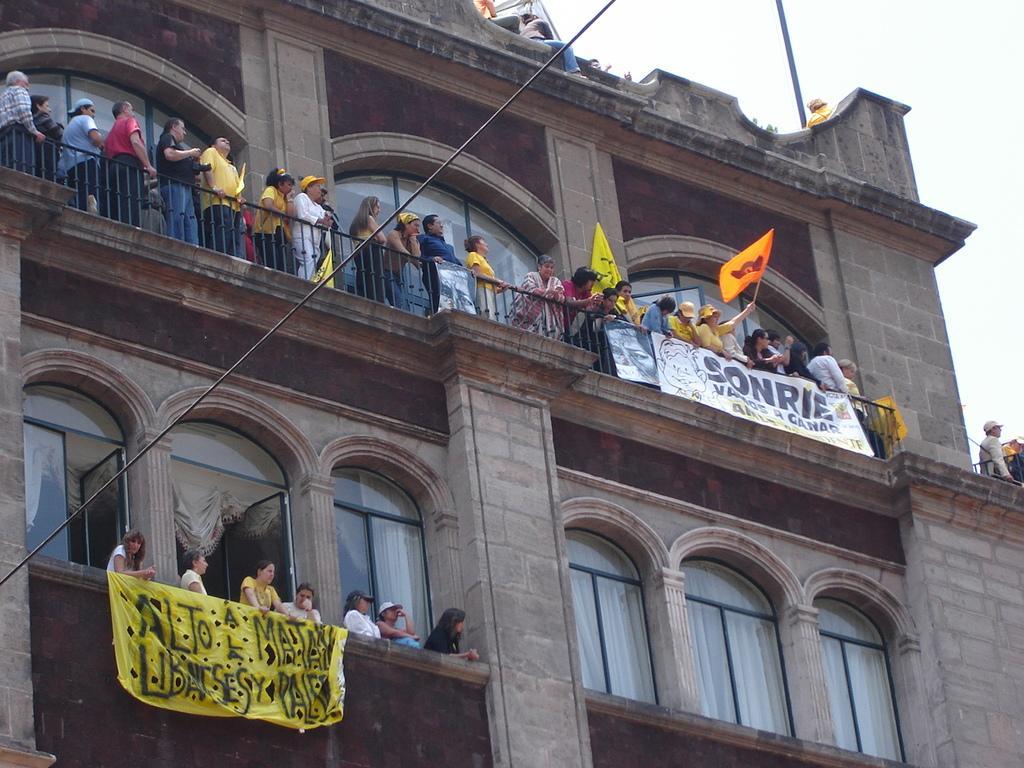Can you describe this image briefly? There is a building and many people are standing at the balcony of top floor, they are holding some flags and banners and in the second floor also there are a group of women standing in the balcony and they are holding a yellow color banner, some people are sitting on the terrace wall of the building and in the background there is a sky. 